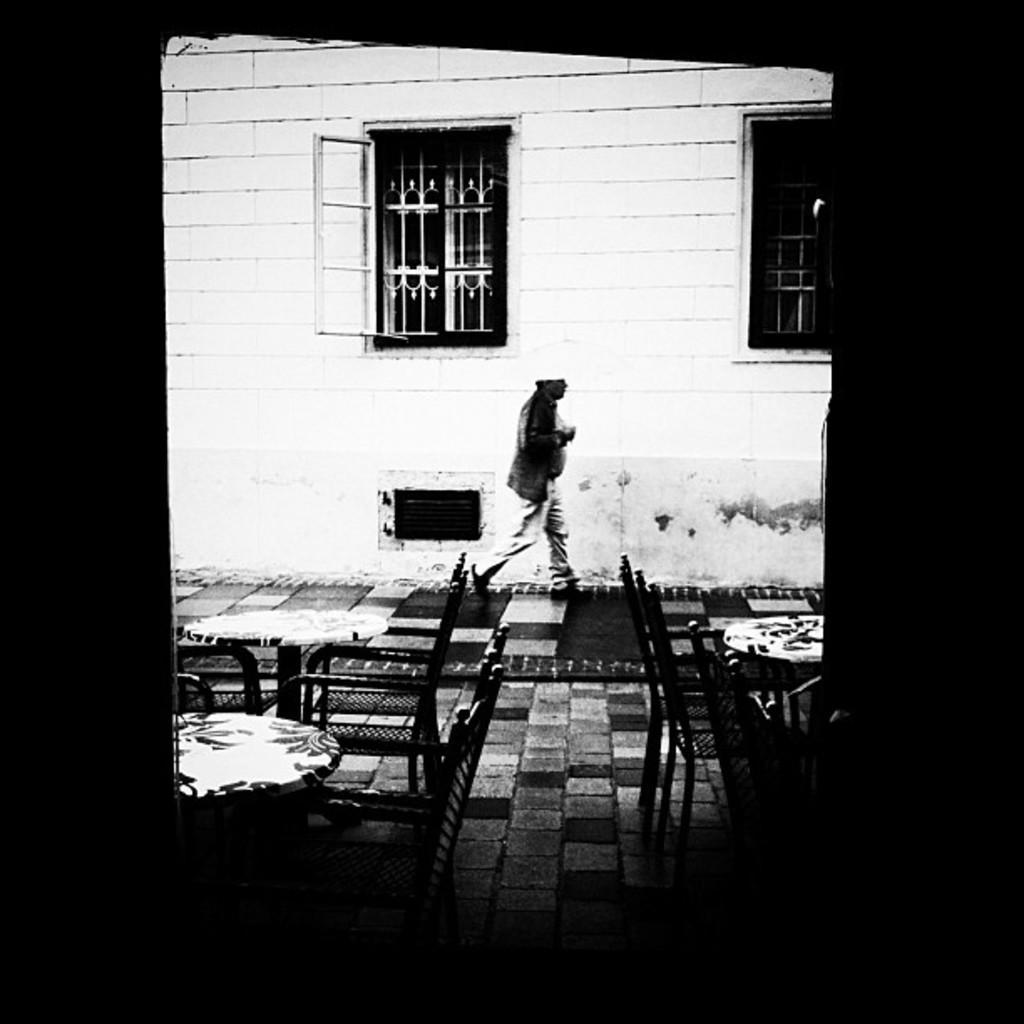Please provide a concise description of this image. In this image there are few chairs and tables on the floor. A person is walking on the floor. Background there is a wall having windows. Front side of the image there is a wall having an entrance. 